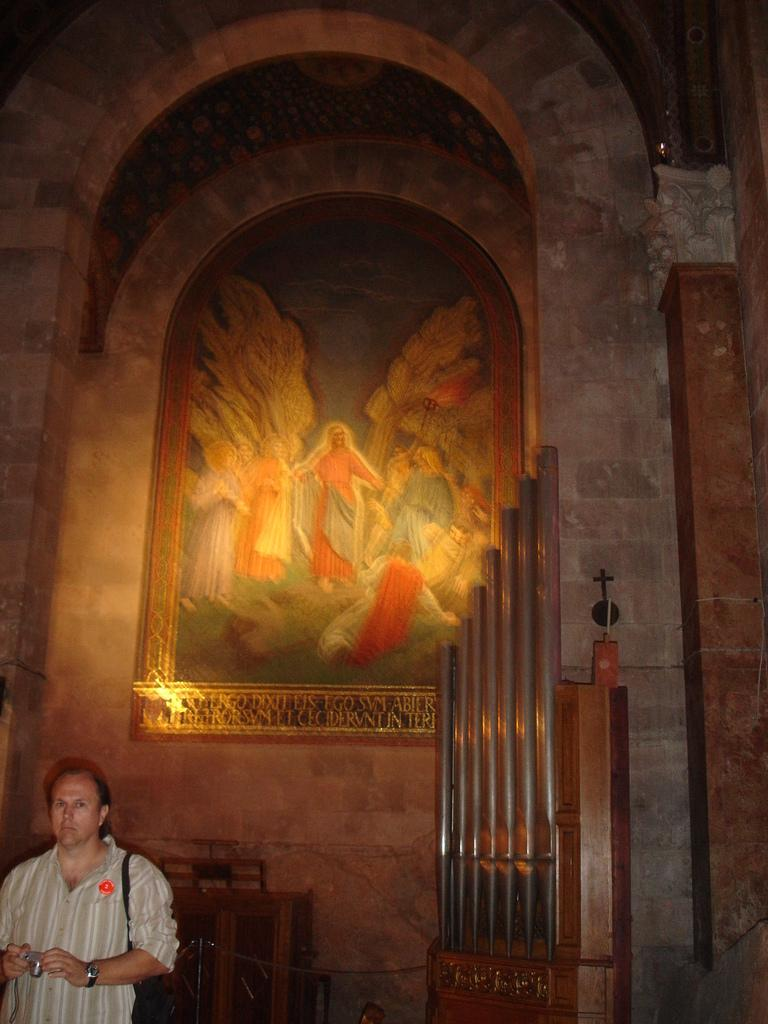What is the person in the image doing? The person is standing in the image and holding a camera in his hand. What object can be seen on the table in the image? There is a frame attached to the table in the image. What is the wooden structure in the image consist of? The wooden structure in the image consists of a few rods. What chance does the person have of winning a vacation in the image? There is no information about a chance or vacation in the image; it only shows a person holding a camera, a table with a frame, and a wooden structure with rods. 